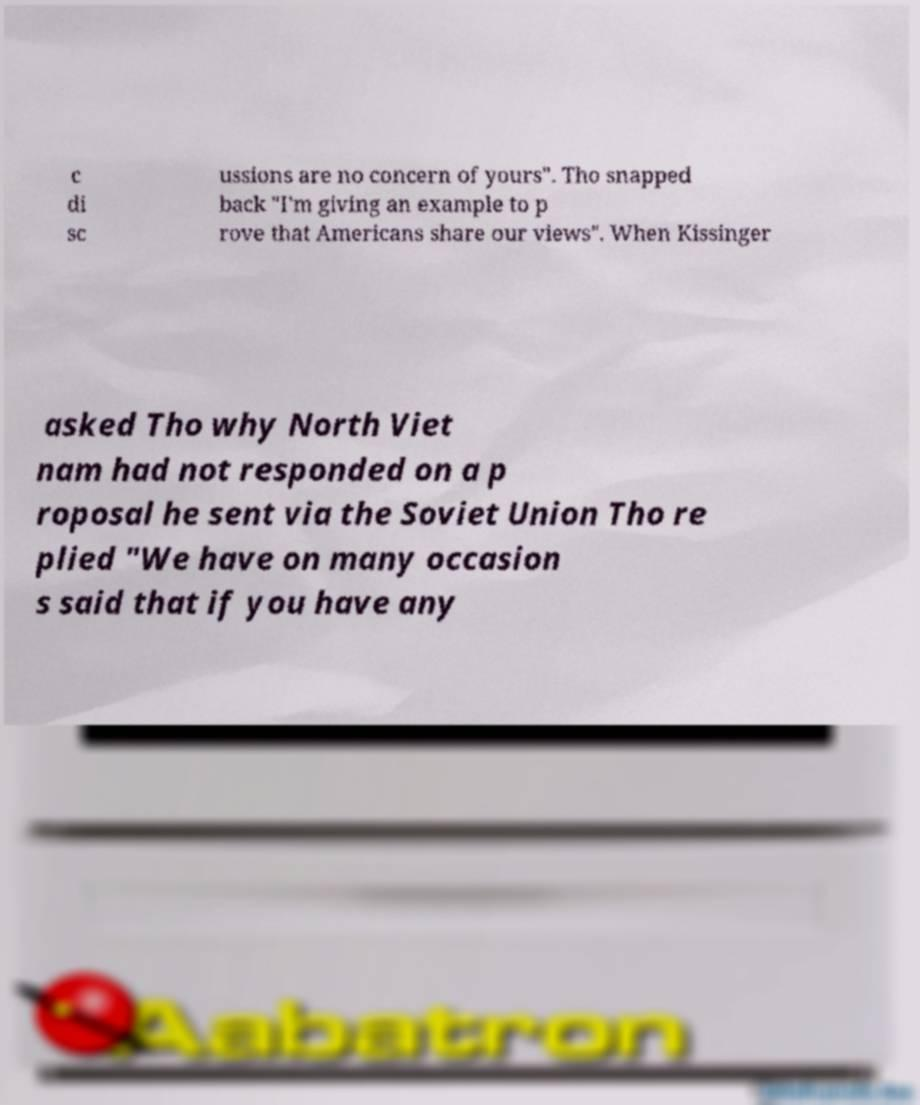Can you read and provide the text displayed in the image?This photo seems to have some interesting text. Can you extract and type it out for me? c di sc ussions are no concern of yours". Tho snapped back "I'm giving an example to p rove that Americans share our views". When Kissinger asked Tho why North Viet nam had not responded on a p roposal he sent via the Soviet Union Tho re plied "We have on many occasion s said that if you have any 